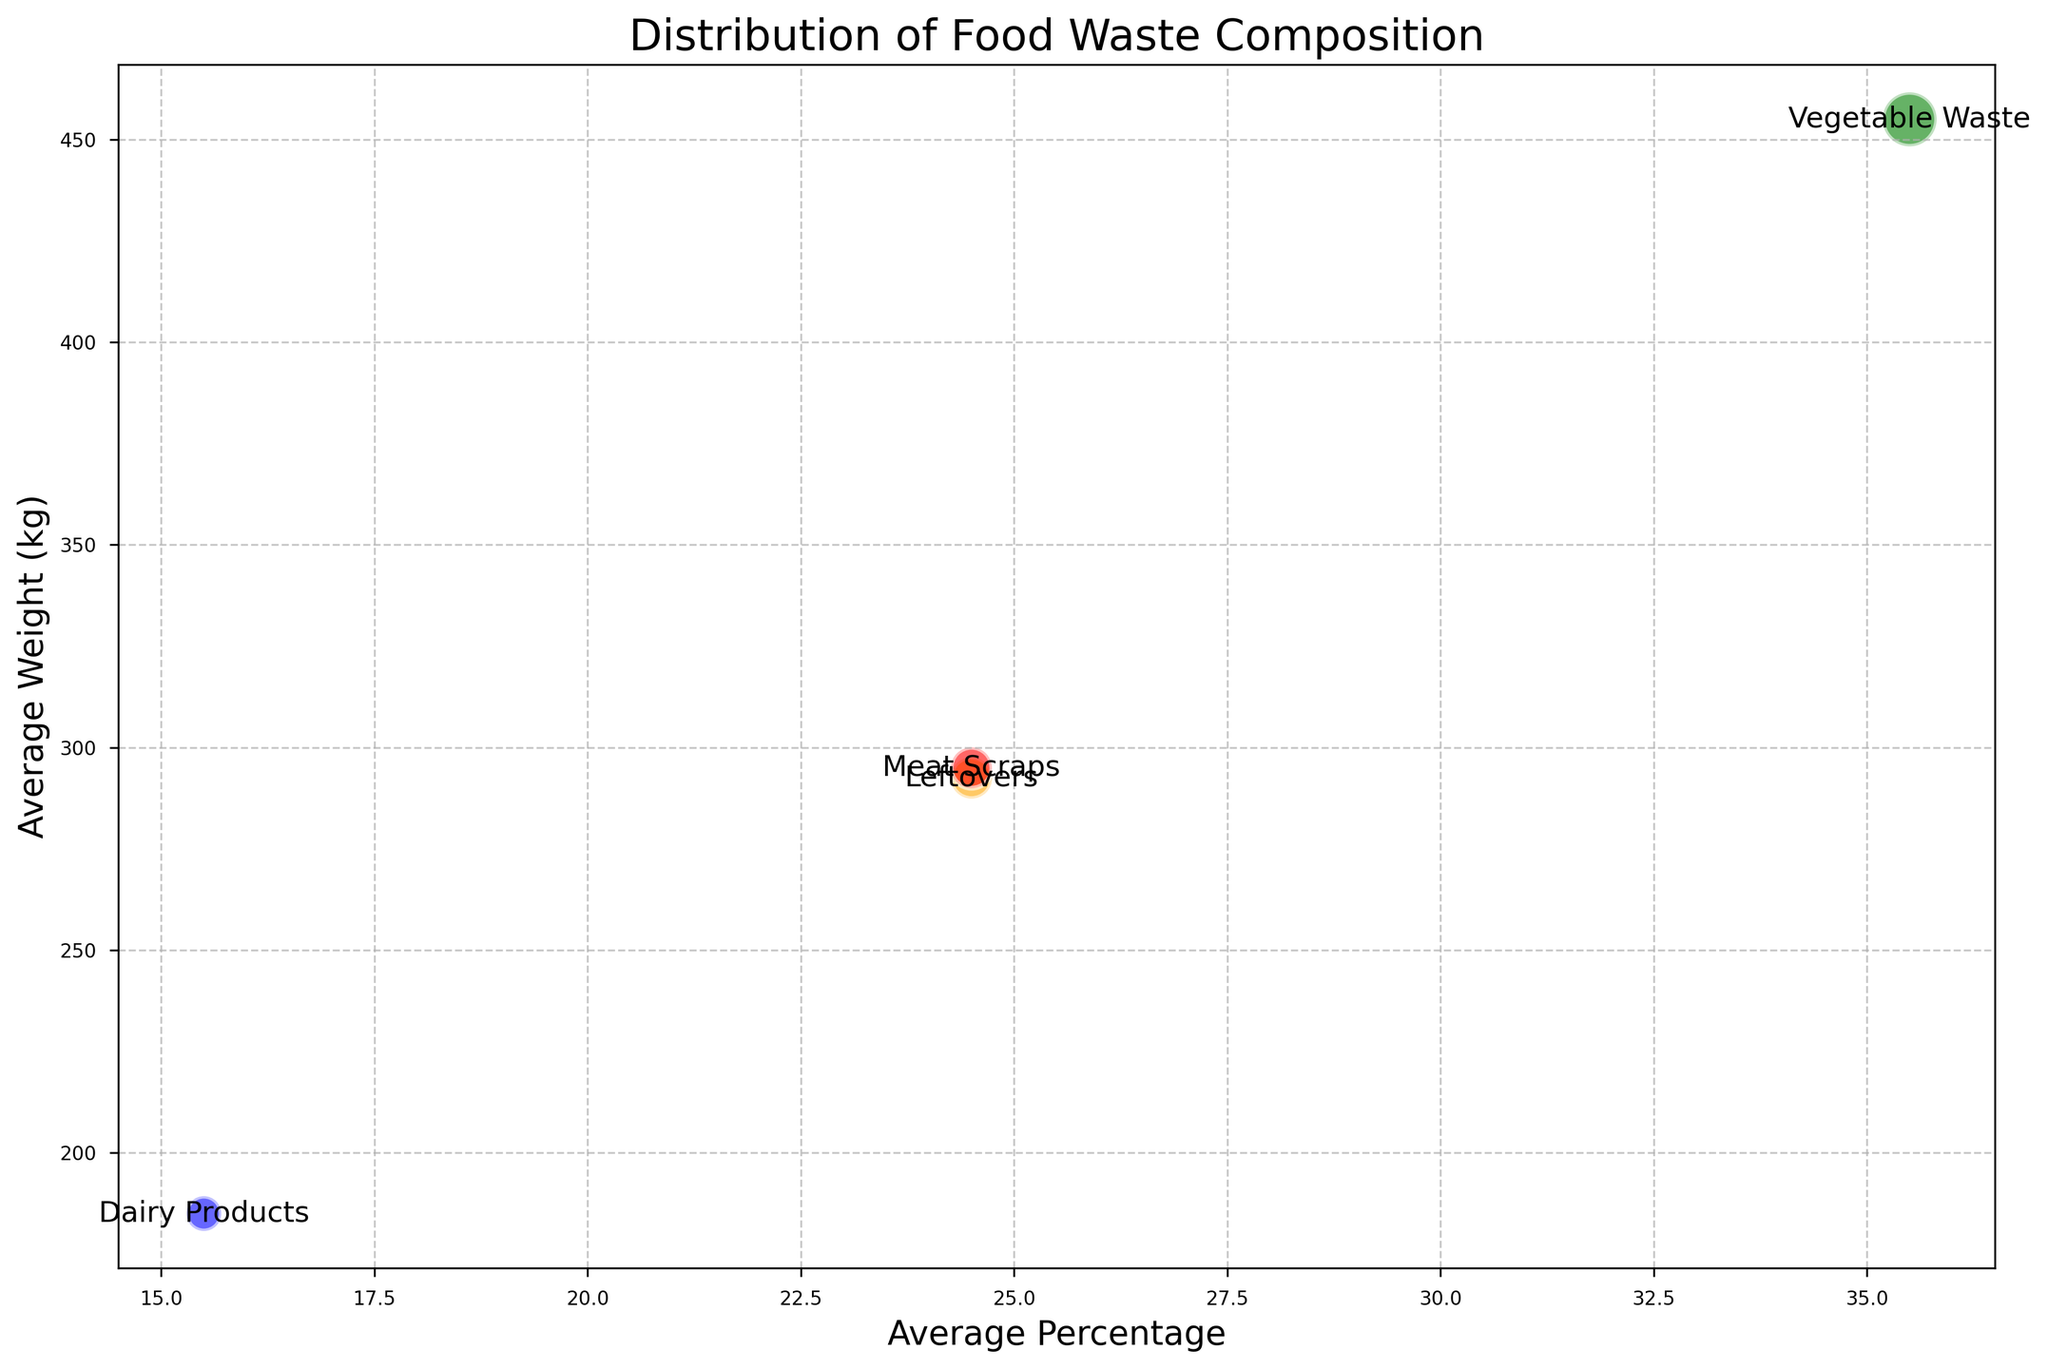What's the average weight of Dairy Products and Leftovers combined? Sum the average weights of Dairy Products (185 kg) and Leftovers (292.5 kg) and then divide by 2 to get the average: (185 + 292.5) / 2 = 238.75
Answer: 238.75 kg Which category has the highest frequency? Looking at the bubble sizes (proportional to frequency), Vegetable Waste has the largest bubbles, indicating the highest frequency.
Answer: Vegetable Waste Is the average percentage of Meat Scraps greater than or less than Dairy Products? The average percentage of Meat Scraps is 24.5%, while Dairy Products is 15.5%. Therefore, Meat Scraps has a greater average percentage.
Answer: Greater What is the total average weight of all categories combined? Sum the average weights of all categories: Vegetable Waste (455 kg), Meat Scraps (297.5 kg), Dairy Products (185 kg), and Leftovers (292.5 kg), then add them: 455 + 297.5 + 185 + 292.5 = 1230
Answer: 1230 kg Which category has the smallest bubble size? Looking at the bubble sizes, Dairy Products has the smallest bubbles, indicating the lowest frequency.
Answer: Dairy Products How much more is the average percentage of Vegetable Waste compared to Leftovers? The average percentage of Vegetable Waste is 35.5%, and Leftovers is 24.5%. Subtracting the two: 35.5 - 24.5 = 11
Answer: 11% What color represents the Meat Scraps category? The visual shows that Meat Scraps bubbles are colored red.
Answer: Red 